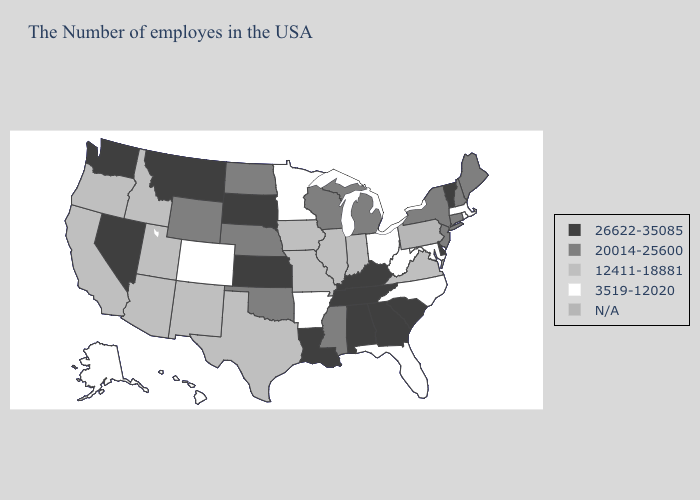What is the value of Mississippi?
Short answer required. 20014-25600. What is the highest value in states that border Nebraska?
Write a very short answer. 26622-35085. What is the value of Missouri?
Keep it brief. 12411-18881. Name the states that have a value in the range N/A?
Write a very short answer. Pennsylvania. What is the lowest value in states that border Virginia?
Answer briefly. 3519-12020. What is the value of Connecticut?
Quick response, please. 20014-25600. What is the value of Minnesota?
Keep it brief. 3519-12020. Name the states that have a value in the range 3519-12020?
Concise answer only. Massachusetts, Rhode Island, Maryland, North Carolina, West Virginia, Ohio, Florida, Arkansas, Minnesota, Colorado, Alaska, Hawaii. Does New York have the lowest value in the USA?
Give a very brief answer. No. Name the states that have a value in the range N/A?
Concise answer only. Pennsylvania. Does the first symbol in the legend represent the smallest category?
Keep it brief. No. Among the states that border Oklahoma , does Texas have the lowest value?
Concise answer only. No. Name the states that have a value in the range 12411-18881?
Answer briefly. Virginia, Indiana, Illinois, Missouri, Iowa, Texas, New Mexico, Utah, Arizona, Idaho, California, Oregon. Among the states that border Nebraska , does Colorado have the lowest value?
Be succinct. Yes. 